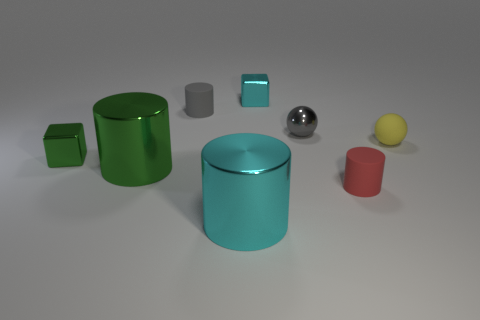Is there a pattern to the arrangement of these objects? The objects seem to be arranged somewhat randomly, without an apparent deliberate pattern. However, their placement allows clear visibility for each item, which could be intentional for purposes of display or analysis. 